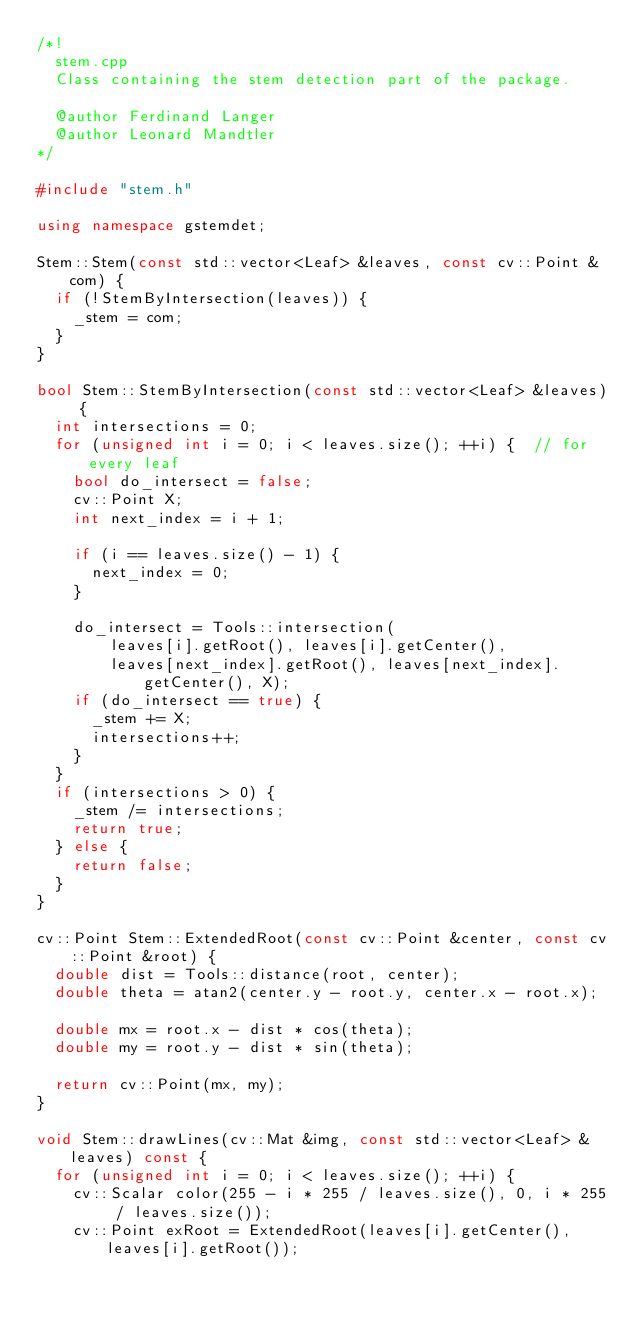Convert code to text. <code><loc_0><loc_0><loc_500><loc_500><_C++_>/*!
  stem.cpp
  Class containing the stem detection part of the package.

  @author Ferdinand Langer
  @author Leonard Mandtler
*/

#include "stem.h"

using namespace gstemdet;

Stem::Stem(const std::vector<Leaf> &leaves, const cv::Point &com) {
  if (!StemByIntersection(leaves)) {
    _stem = com;
  }
}

bool Stem::StemByIntersection(const std::vector<Leaf> &leaves) {
  int intersections = 0;
  for (unsigned int i = 0; i < leaves.size(); ++i) {  // for every leaf
    bool do_intersect = false;
    cv::Point X;
    int next_index = i + 1;

    if (i == leaves.size() - 1) {
      next_index = 0;
    }

    do_intersect = Tools::intersection(
        leaves[i].getRoot(), leaves[i].getCenter(),
        leaves[next_index].getRoot(), leaves[next_index].getCenter(), X);
    if (do_intersect == true) {
      _stem += X;
      intersections++;
    }
  }
  if (intersections > 0) {
    _stem /= intersections;
    return true;
  } else {
    return false;
  }
}

cv::Point Stem::ExtendedRoot(const cv::Point &center, const cv::Point &root) {
  double dist = Tools::distance(root, center);
  double theta = atan2(center.y - root.y, center.x - root.x);

  double mx = root.x - dist * cos(theta);
  double my = root.y - dist * sin(theta);

  return cv::Point(mx, my);
}

void Stem::drawLines(cv::Mat &img, const std::vector<Leaf> &leaves) const {
  for (unsigned int i = 0; i < leaves.size(); ++i) {
    cv::Scalar color(255 - i * 255 / leaves.size(), 0, i * 255 / leaves.size());
    cv::Point exRoot = ExtendedRoot(leaves[i].getCenter(), leaves[i].getRoot());</code> 